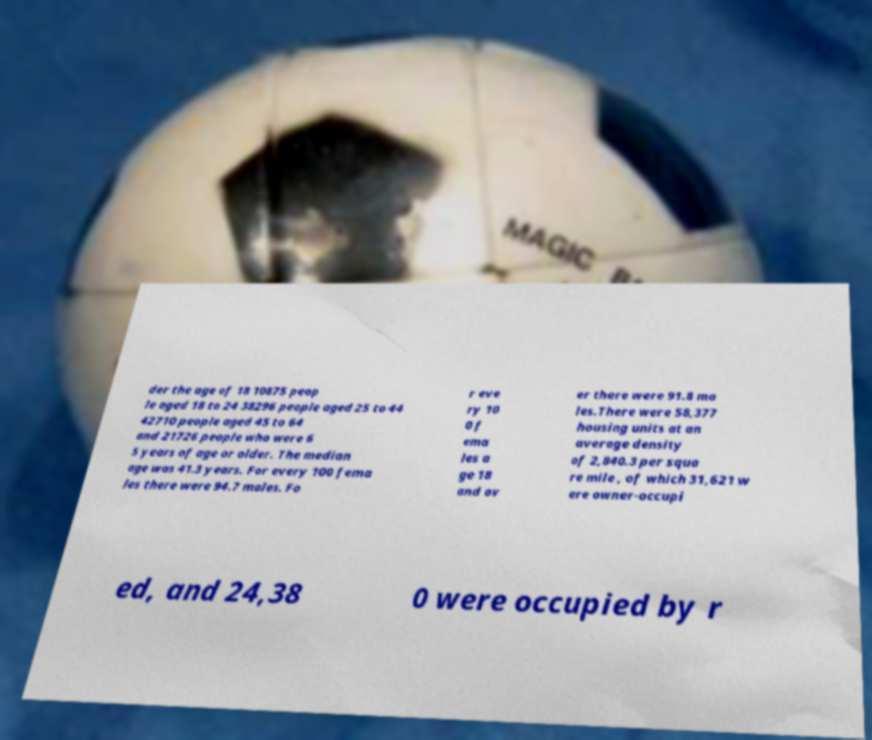Please read and relay the text visible in this image. What does it say? der the age of 18 10875 peop le aged 18 to 24 38296 people aged 25 to 44 42710 people aged 45 to 64 and 21726 people who were 6 5 years of age or older. The median age was 41.3 years. For every 100 fema les there were 94.7 males. Fo r eve ry 10 0 f ema les a ge 18 and ov er there were 91.8 ma les.There were 58,377 housing units at an average density of 2,840.3 per squa re mile , of which 31,621 w ere owner-occupi ed, and 24,38 0 were occupied by r 